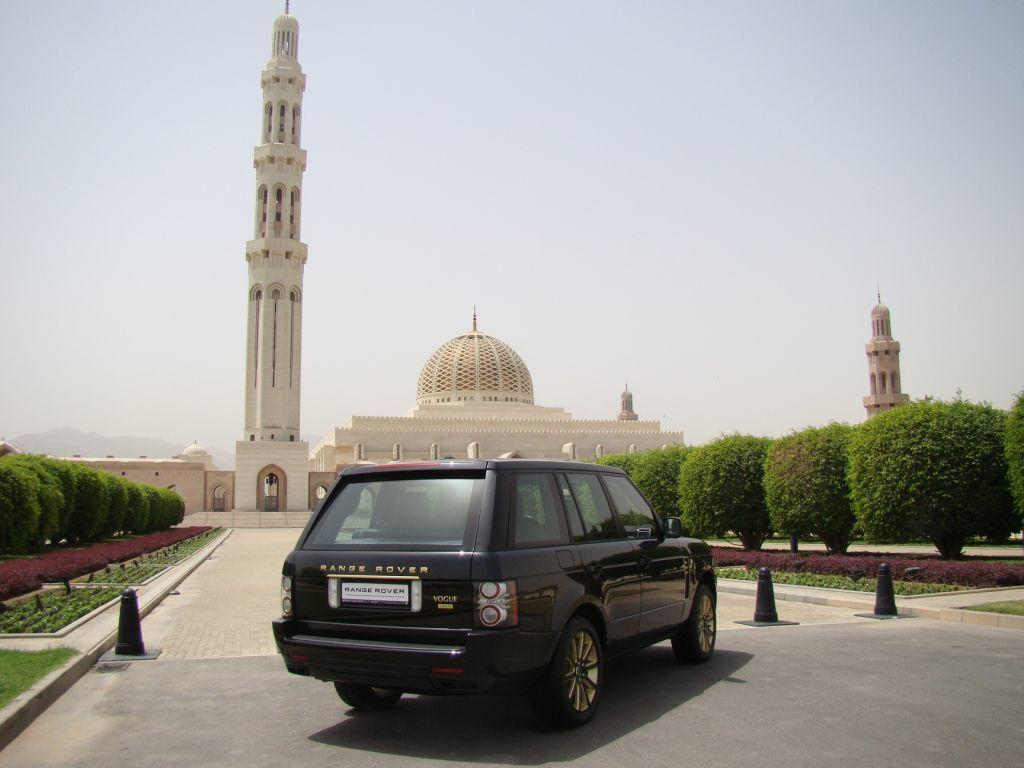<image>
Share a concise interpretation of the image provided. A Range Rover is parked in front of cones blocking the entrance to ornate buildings. 